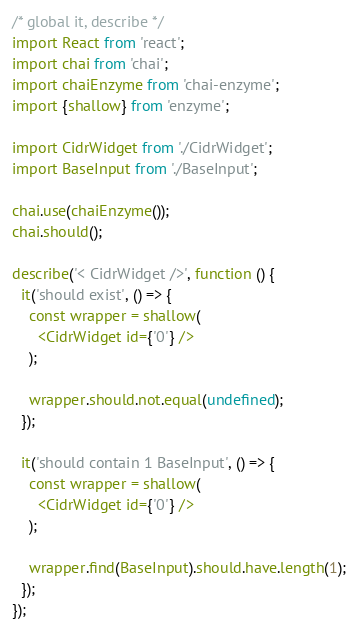Convert code to text. <code><loc_0><loc_0><loc_500><loc_500><_JavaScript_>/* global it, describe */
import React from 'react';
import chai from 'chai';
import chaiEnzyme from 'chai-enzyme';
import {shallow} from 'enzyme';

import CidrWidget from './CidrWidget';
import BaseInput from './BaseInput';

chai.use(chaiEnzyme());
chai.should();

describe('< CidrWidget />', function () {
  it('should exist', () => {
    const wrapper = shallow(
      <CidrWidget id={'0'} />
    );

    wrapper.should.not.equal(undefined);
  });

  it('should contain 1 BaseInput', () => {
    const wrapper = shallow(
      <CidrWidget id={'0'} />
    );

    wrapper.find(BaseInput).should.have.length(1);
  });
});
</code> 